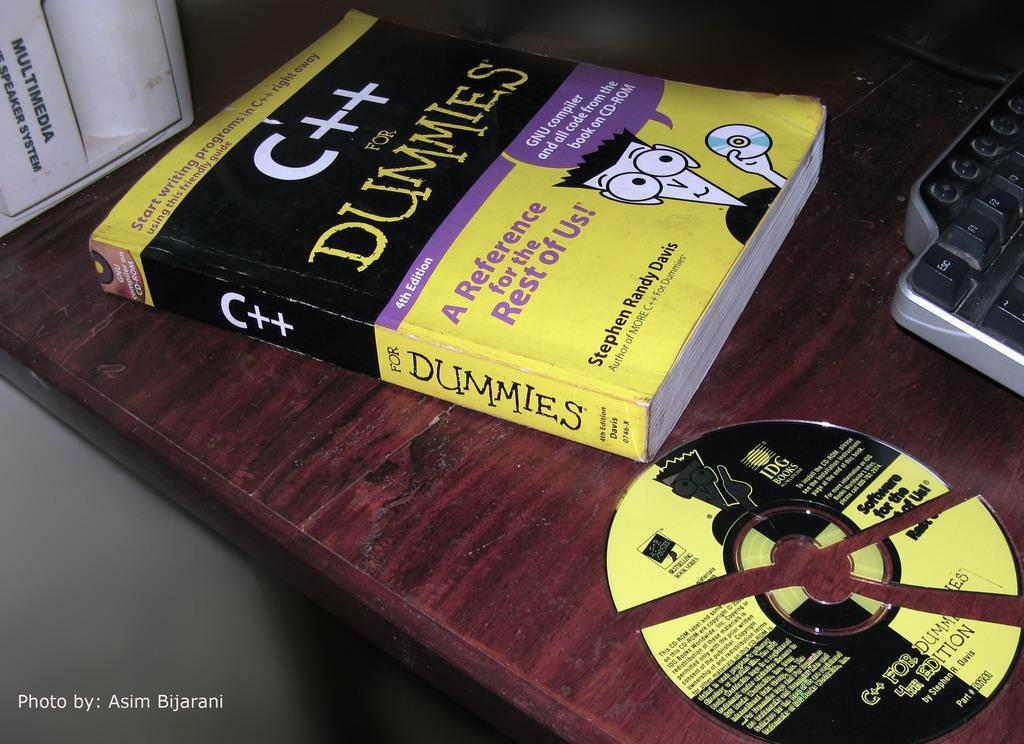<image>
Create a compact narrative representing the image presented. A yellow and black book for dummies about C++ 